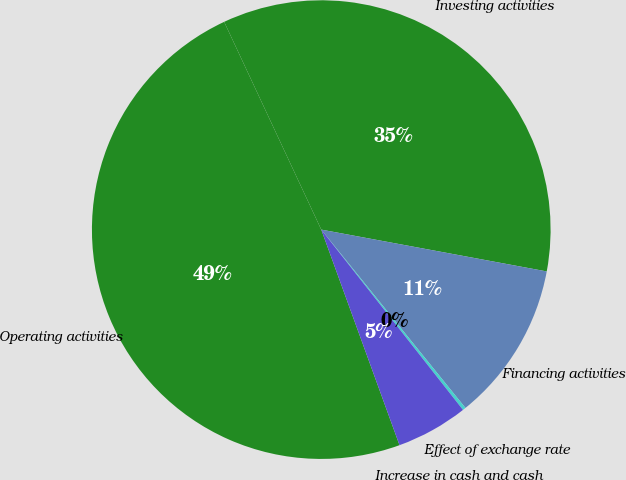<chart> <loc_0><loc_0><loc_500><loc_500><pie_chart><fcel>Operating activities<fcel>Investing activities<fcel>Financing activities<fcel>Effect of exchange rate<fcel>Increase in cash and cash<nl><fcel>48.59%<fcel>34.88%<fcel>11.26%<fcel>0.22%<fcel>5.06%<nl></chart> 